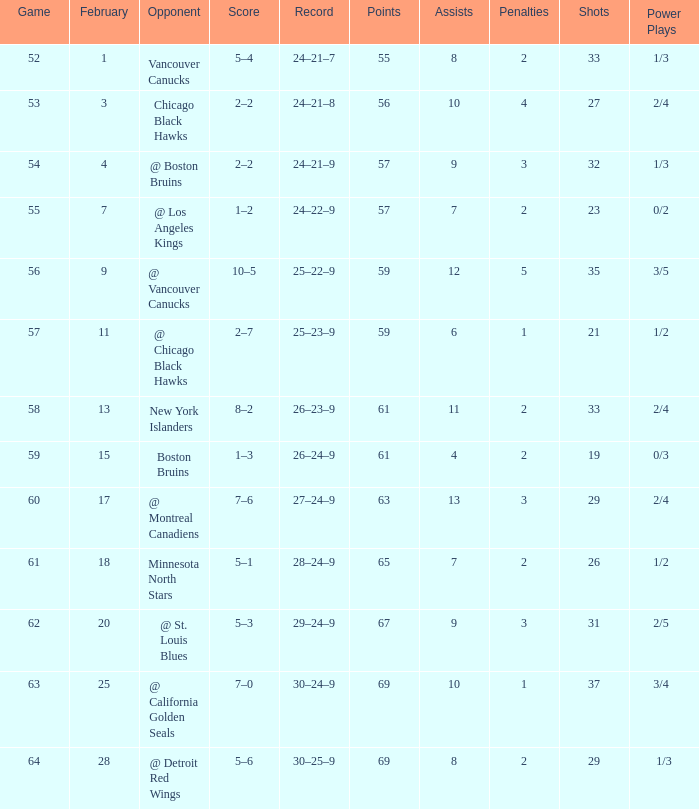How many games have a record of 30–25–9 and more points than 69? 0.0. 